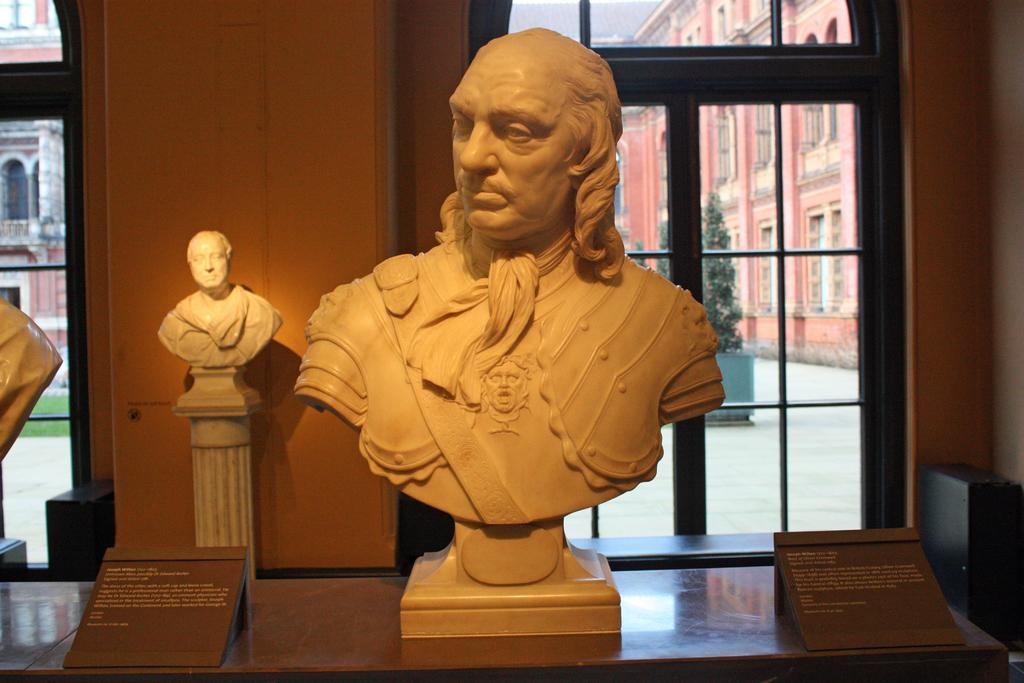What can be seen in the image that represents artistic creations? There are statues in the image. What is on the table in the image? There are brown boards on a table in the image. What can be seen in the distance in the image? There are buildings, trees, and glass windows visible in the background of the image. What type of trousers is the statue wearing in the image? The statues in the image do not have clothing, as they are not real people. 